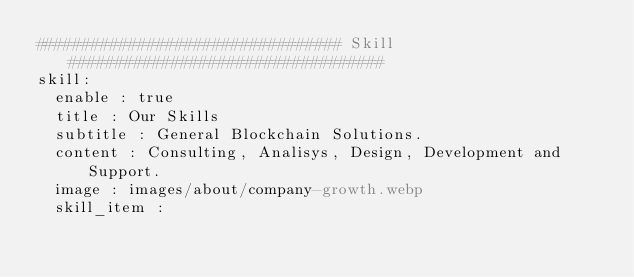Convert code to text. <code><loc_0><loc_0><loc_500><loc_500><_YAML_>################################# Skill ##################################
skill:
  enable : true
  title : Our Skills
  subtitle : General Blockchain Solutions.
  content : Consulting, Analisys, Design, Development and Support.
  image : images/about/company-growth.webp
  skill_item :
      </code> 